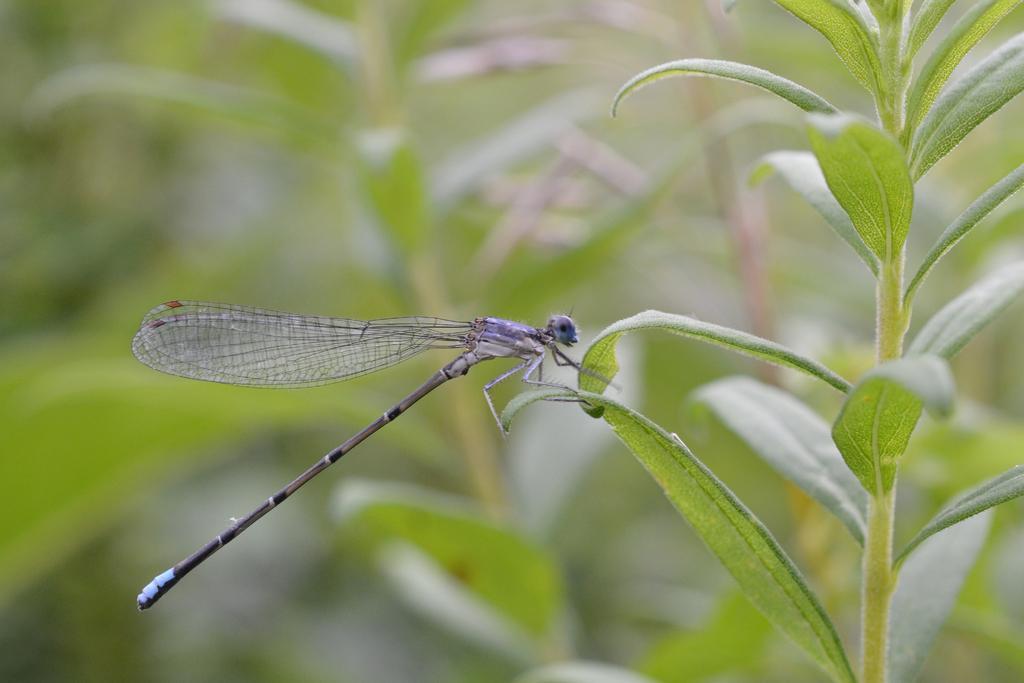How would you summarize this image in a sentence or two? In this image I can see an insect which is purple in color is on the leaf of a plant which is green in color. I ca see the blurry background in which I can see few plants. 